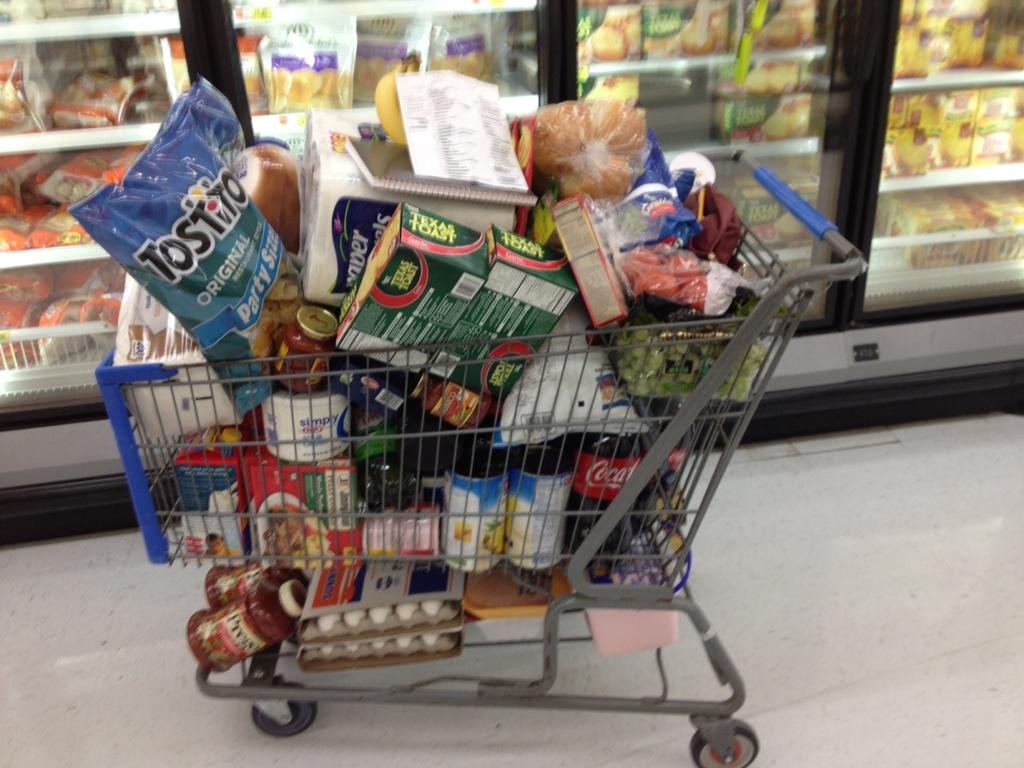What kind of soda is there?
Offer a terse response. Coca cola. 